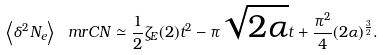<formula> <loc_0><loc_0><loc_500><loc_500>\left \langle \delta ^ { 2 } N _ { e } \right \rangle _ { \ } m r { C N } \simeq \frac { 1 } { 2 } \zeta _ { E } ( 2 ) t ^ { 2 } - \pi \sqrt { 2 \alpha } t + \frac { \pi ^ { 2 } } { 4 } ( 2 \alpha ) ^ { \frac { 3 } { 2 } } .</formula> 